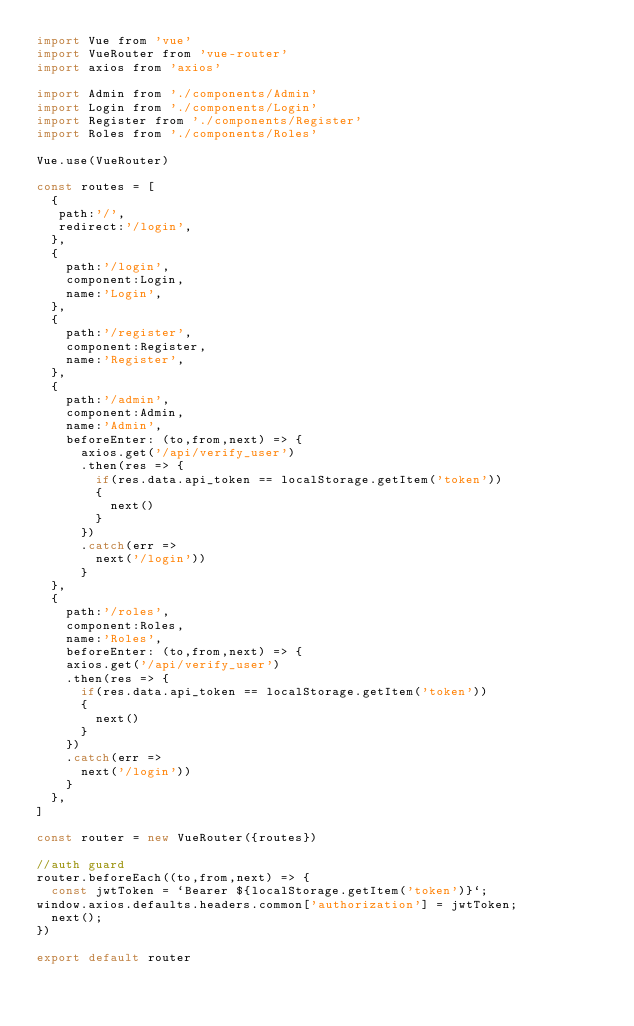Convert code to text. <code><loc_0><loc_0><loc_500><loc_500><_JavaScript_>import Vue from 'vue'
import VueRouter from 'vue-router'
import axios from 'axios'

import Admin from './components/Admin'
import Login from './components/Login'
import Register from './components/Register'
import Roles from './components/Roles'

Vue.use(VueRouter)

const routes = [
  {
   path:'/',
   redirect:'/login',
  },
  {
    path:'/login',
    component:Login,
    name:'Login',
  },
  {
    path:'/register',
    component:Register,
    name:'Register',
  },
  {
    path:'/admin',
    component:Admin,
    name:'Admin',
    beforeEnter: (to,from,next) => {
      axios.get('/api/verify_user')
      .then(res => {
        if(res.data.api_token == localStorage.getItem('token'))
        {
          next()
        }
      })
      .catch(err => 
        next('/login'))
      }
  },
  {
    path:'/roles',
    component:Roles,
    name:'Roles',
    beforeEnter: (to,from,next) => {
    axios.get('/api/verify_user')
    .then(res => {
      if(res.data.api_token == localStorage.getItem('token'))
      {
        next()
      }
    })
    .catch(err => 
      next('/login'))
    }
  },
]

const router = new VueRouter({routes})

//auth guard
router.beforeEach((to,from,next) => {
  const jwtToken = `Bearer ${localStorage.getItem('token')}`;
window.axios.defaults.headers.common['authorization'] = jwtToken;
  next();
})

export default router</code> 